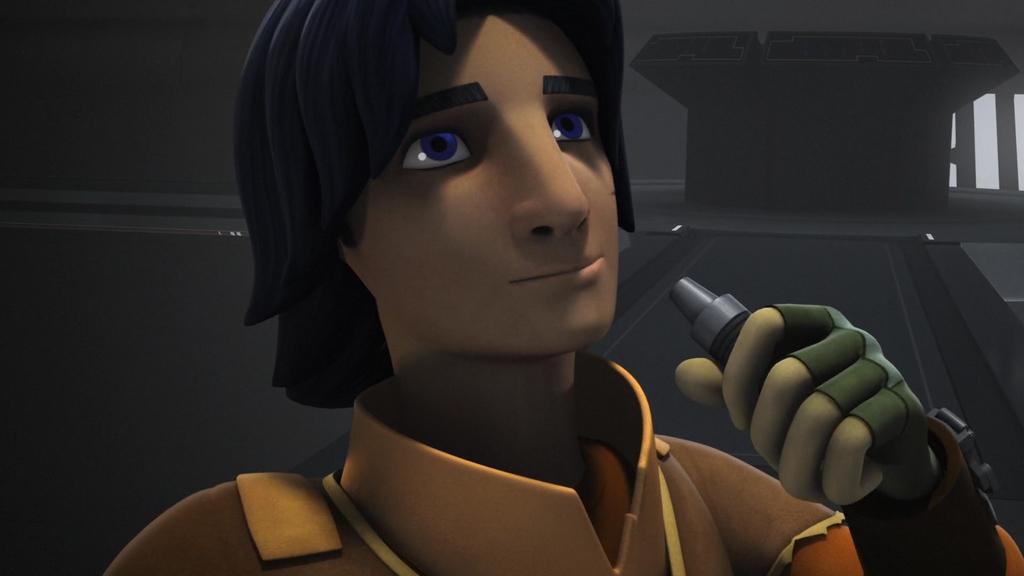Could you give a brief overview of what you see in this image? This image is an animation. In this animation we can see a person holding an object. In the background we can see a wall and an object. 